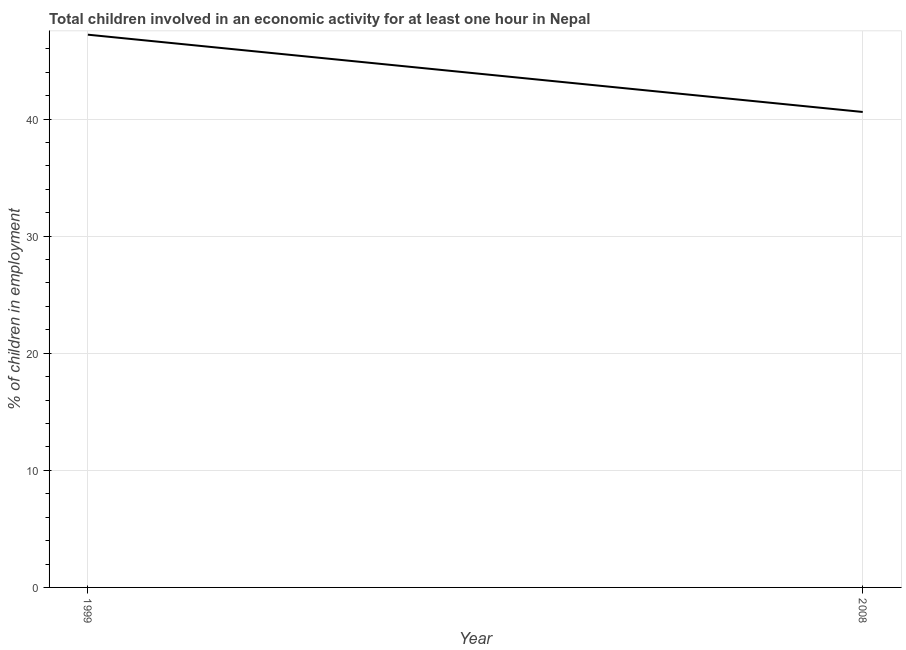What is the percentage of children in employment in 1999?
Ensure brevity in your answer.  47.2. Across all years, what is the maximum percentage of children in employment?
Your answer should be compact. 47.2. Across all years, what is the minimum percentage of children in employment?
Your answer should be compact. 40.6. In which year was the percentage of children in employment minimum?
Make the answer very short. 2008. What is the sum of the percentage of children in employment?
Make the answer very short. 87.8. What is the difference between the percentage of children in employment in 1999 and 2008?
Make the answer very short. 6.6. What is the average percentage of children in employment per year?
Offer a terse response. 43.9. What is the median percentage of children in employment?
Provide a short and direct response. 43.9. In how many years, is the percentage of children in employment greater than 20 %?
Make the answer very short. 2. What is the ratio of the percentage of children in employment in 1999 to that in 2008?
Your answer should be compact. 1.16. Is the percentage of children in employment in 1999 less than that in 2008?
Keep it short and to the point. No. In how many years, is the percentage of children in employment greater than the average percentage of children in employment taken over all years?
Your response must be concise. 1. How many lines are there?
Your answer should be compact. 1. How many years are there in the graph?
Offer a terse response. 2. What is the difference between two consecutive major ticks on the Y-axis?
Offer a terse response. 10. Are the values on the major ticks of Y-axis written in scientific E-notation?
Make the answer very short. No. Does the graph contain any zero values?
Keep it short and to the point. No. Does the graph contain grids?
Make the answer very short. Yes. What is the title of the graph?
Keep it short and to the point. Total children involved in an economic activity for at least one hour in Nepal. What is the label or title of the Y-axis?
Your answer should be compact. % of children in employment. What is the % of children in employment of 1999?
Give a very brief answer. 47.2. What is the % of children in employment of 2008?
Give a very brief answer. 40.6. What is the difference between the % of children in employment in 1999 and 2008?
Make the answer very short. 6.6. What is the ratio of the % of children in employment in 1999 to that in 2008?
Ensure brevity in your answer.  1.16. 